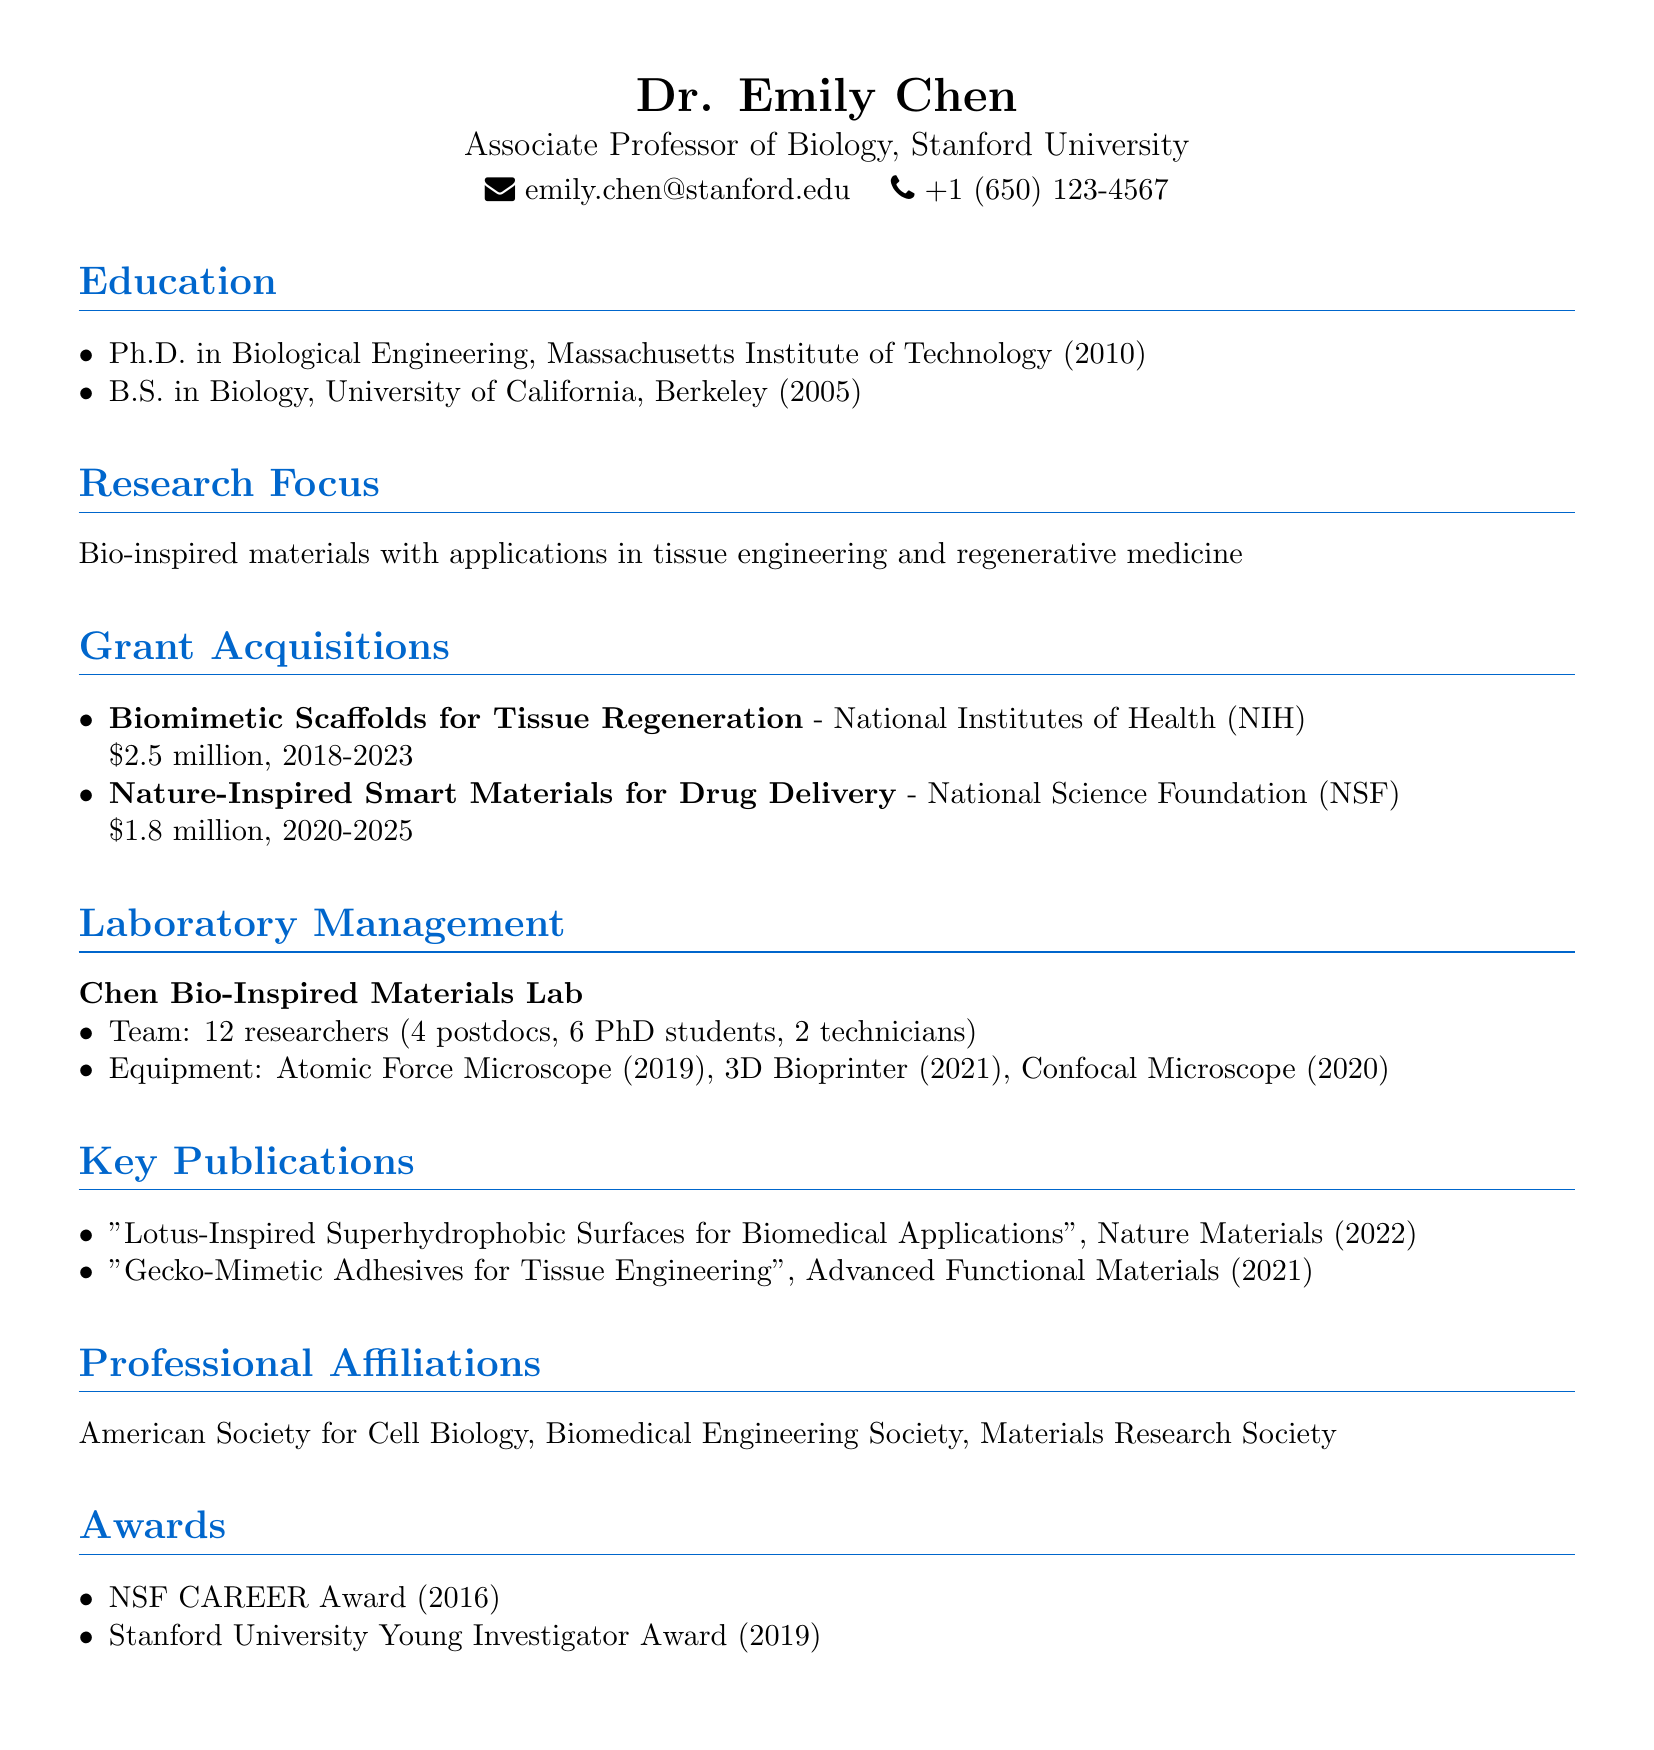What is Dr. Emily Chen's title? Dr. Emily Chen's title is provided in the document, and it is "Associate Professor of Biology."
Answer: Associate Professor of Biology Which university did Dr. Chen receive her Ph.D. from? The university where Dr. Chen received her Ph.D. is mentioned in the education section, which is the Massachusetts Institute of Technology.
Answer: Massachusetts Institute of Technology How much funding was acquired for the "Biomimetic Scaffolds for Tissue Regeneration" project? The specific amount of funding for this grant acquisition is listed in the document, which is $2.5 million.
Answer: $2.5 million In what year did Dr. Chen receive the NSF CAREER Award? The year when Dr. Chen received the NSF CAREER Award is stated under the awards section, which is 2016.
Answer: 2016 What is the size of the team in the Chen Bio-Inspired Materials Lab? The team size in the laboratory management section indicates a total of 12 researchers.
Answer: 12 researchers What is the main research focus of Dr. Chen? The main research focus is summarized in the document under the research focus section, which involves bio-inspired materials with applications in tissue engineering and regenerative medicine.
Answer: Bio-inspired materials with applications in tissue engineering and regenerative medicine Which equipment was acquired in 2021? The document lists new equipment in the laboratory management section, and the equipment acquired in 2021 is the 3D Bioprinter.
Answer: 3D Bioprinter Which journal published the publication titled "Lotus-Inspired Superhydrophobic Surfaces for Biomedical Applications"? The journal that published this specific publication is mentioned in the key publications section, which is Nature Materials.
Answer: Nature Materials 